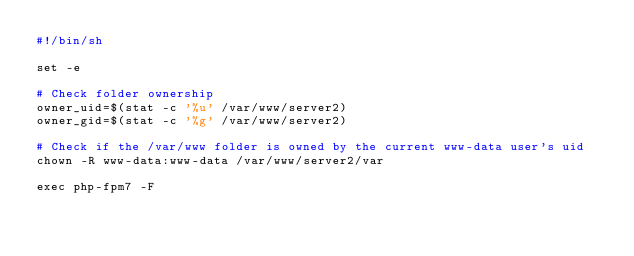<code> <loc_0><loc_0><loc_500><loc_500><_Bash_>#!/bin/sh

set -e

# Check folder ownership
owner_uid=$(stat -c '%u' /var/www/server2)
owner_gid=$(stat -c '%g' /var/www/server2)

# Check if the /var/www folder is owned by the current www-data user's uid
chown -R www-data:www-data /var/www/server2/var

exec php-fpm7 -F
</code> 